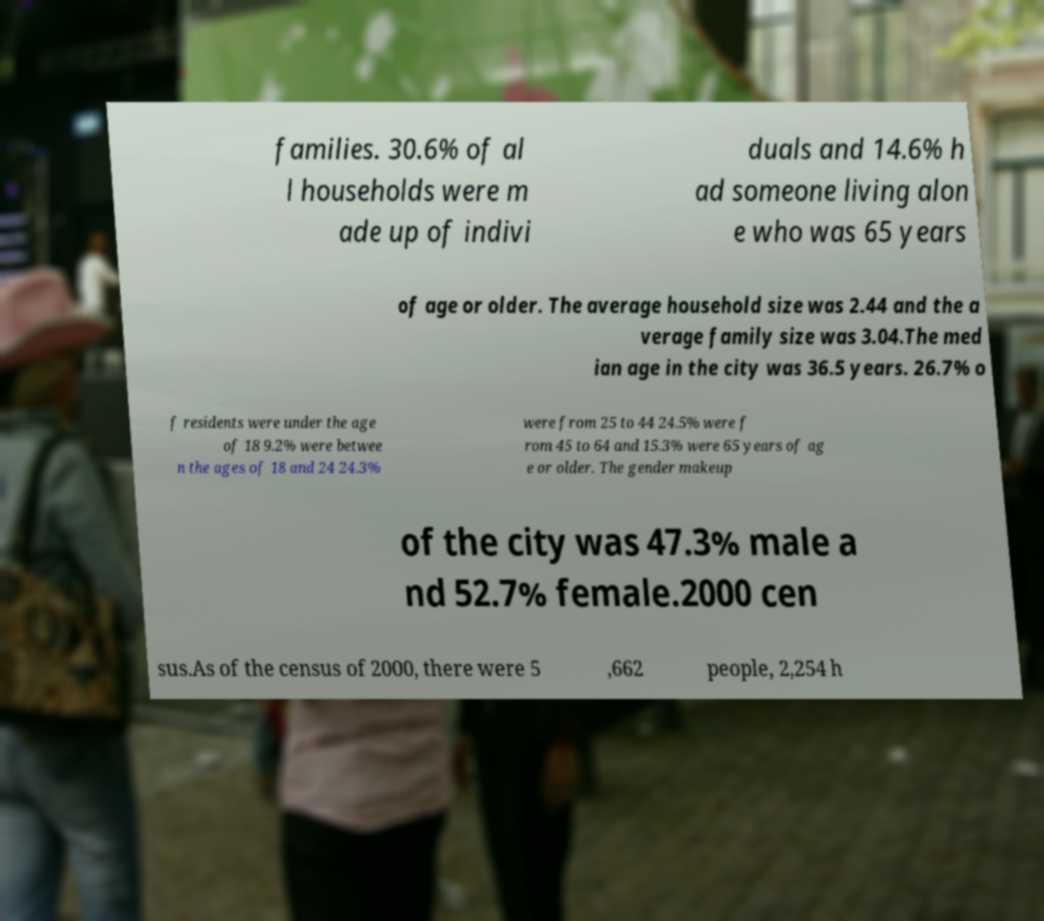Could you extract and type out the text from this image? families. 30.6% of al l households were m ade up of indivi duals and 14.6% h ad someone living alon e who was 65 years of age or older. The average household size was 2.44 and the a verage family size was 3.04.The med ian age in the city was 36.5 years. 26.7% o f residents were under the age of 18 9.2% were betwee n the ages of 18 and 24 24.3% were from 25 to 44 24.5% were f rom 45 to 64 and 15.3% were 65 years of ag e or older. The gender makeup of the city was 47.3% male a nd 52.7% female.2000 cen sus.As of the census of 2000, there were 5 ,662 people, 2,254 h 